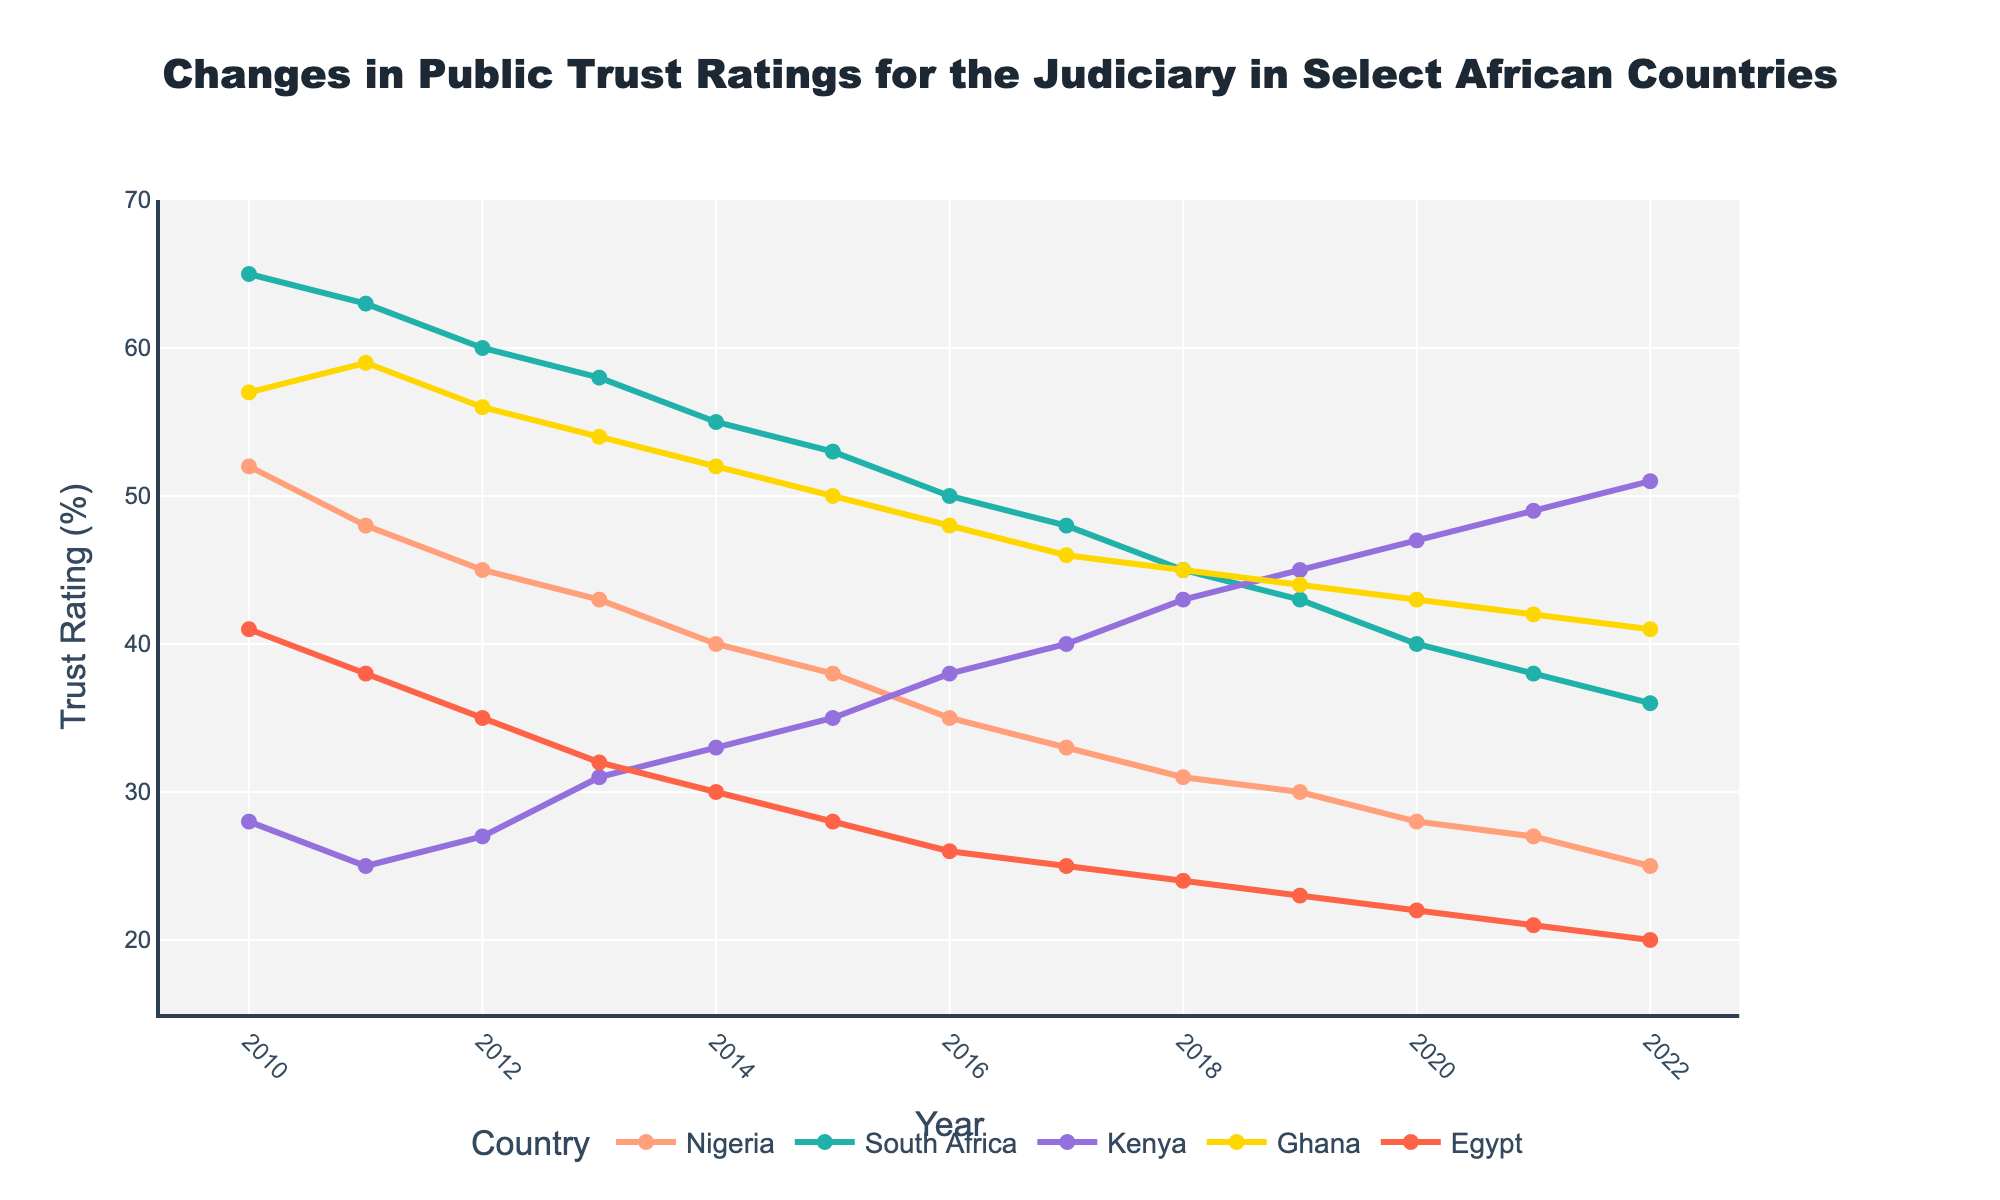What is the trend of public trust ratings for the judiciary in Nigeria from 2010 to 2022? By following the line representing Nigeria, we can see a continuous decline in public trust ratings from 52% in 2010 to 25% in 2022.
Answer: Continuous decline Which country had the highest trust rating in 2015? Observing the plot for the year 2015, South Africa had the highest trust rating at 53%, followed closely by Ghana at 50%.
Answer: South Africa How did the trust rating in South Africa change from 2010 to 2020? Starting from a trust rating of 65% in 2010, South Africa experienced a steady decline to 40% in 2020.
Answer: Declined from 65% to 40% What was the trust rating difference between Kenya and Egypt in 2022? In 2022, Kenya's trust rating was 51%, and Egypt's was 20%. The difference is calculated by subtracting Egypt's rating from Kenya's: 51% - 20% = 31%.
Answer: 31% Which country showed the lowest trust rating in 2022? By observing the ending points of the lines for 2022, Egypt had the lowest trust rating at 20%.
Answer: Egypt What is the average trust rating in Ghana from 2010 to 2022? Summing up Ghana's yearly ratings from 2010 to 2022 yields (57 + 59 + 56 + 54 + 52 + 50 + 48 + 46 + 45 + 44 + 43 + 42 + 41) = 637. There are 13 years of data, so the average rating is 637 / 13 ≈ 49%.
Answer: 49% Between 2010 and 2022, which country showed the most consistent decline in trust ratings? Nigeria's line showed a steady and consistent decline each year from 52% in 2010 to 25% in 2022 without significant fluctuations.
Answer: Nigeria What visual feature indicates the country with the highest trust rating in 2010? The height of the line for South Africa in 2010 is the tallest, indicating it had the highest trust rating at 65%.
Answer: Tallest line in 2010 (South Africa) How did Kenya's trust rating change between 2017 and 2022? Following the line for Kenya from 2017 (40%) to 2022 (51%), we see a steady increase in trust ratings over these years.
Answer: Increase from 40% to 51% Comparing 2010 to 2022, which country experienced the largest drop in trust ratings? Calculating the drop for each country: Nigeria (52% to 25% = 27%), South Africa (65% to 36% = 29%), Kenya (28% to 51% = -23%), Ghana (57% to 41% = 16%), Egypt (41% to 20% = 21%). South Africa experienced the largest drop of 29%.
Answer: South Africa 